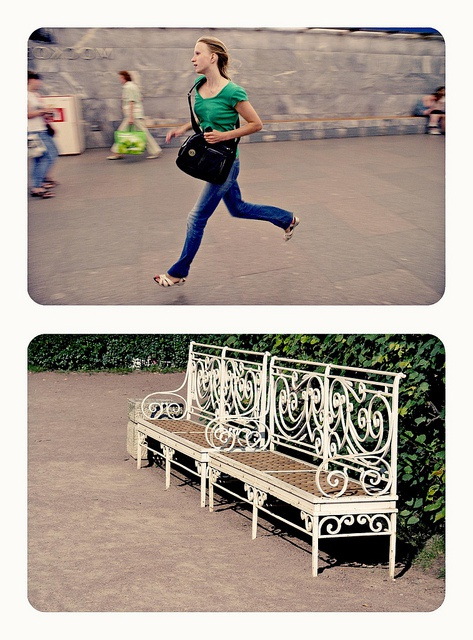Describe the objects in this image and their specific colors. I can see bench in white, ivory, black, tan, and darkgray tones, people in white, black, navy, darkgray, and tan tones, bench in white, gray, and darkgray tones, people in white, gray, and darkgray tones, and handbag in white, black, darkgray, gray, and tan tones in this image. 